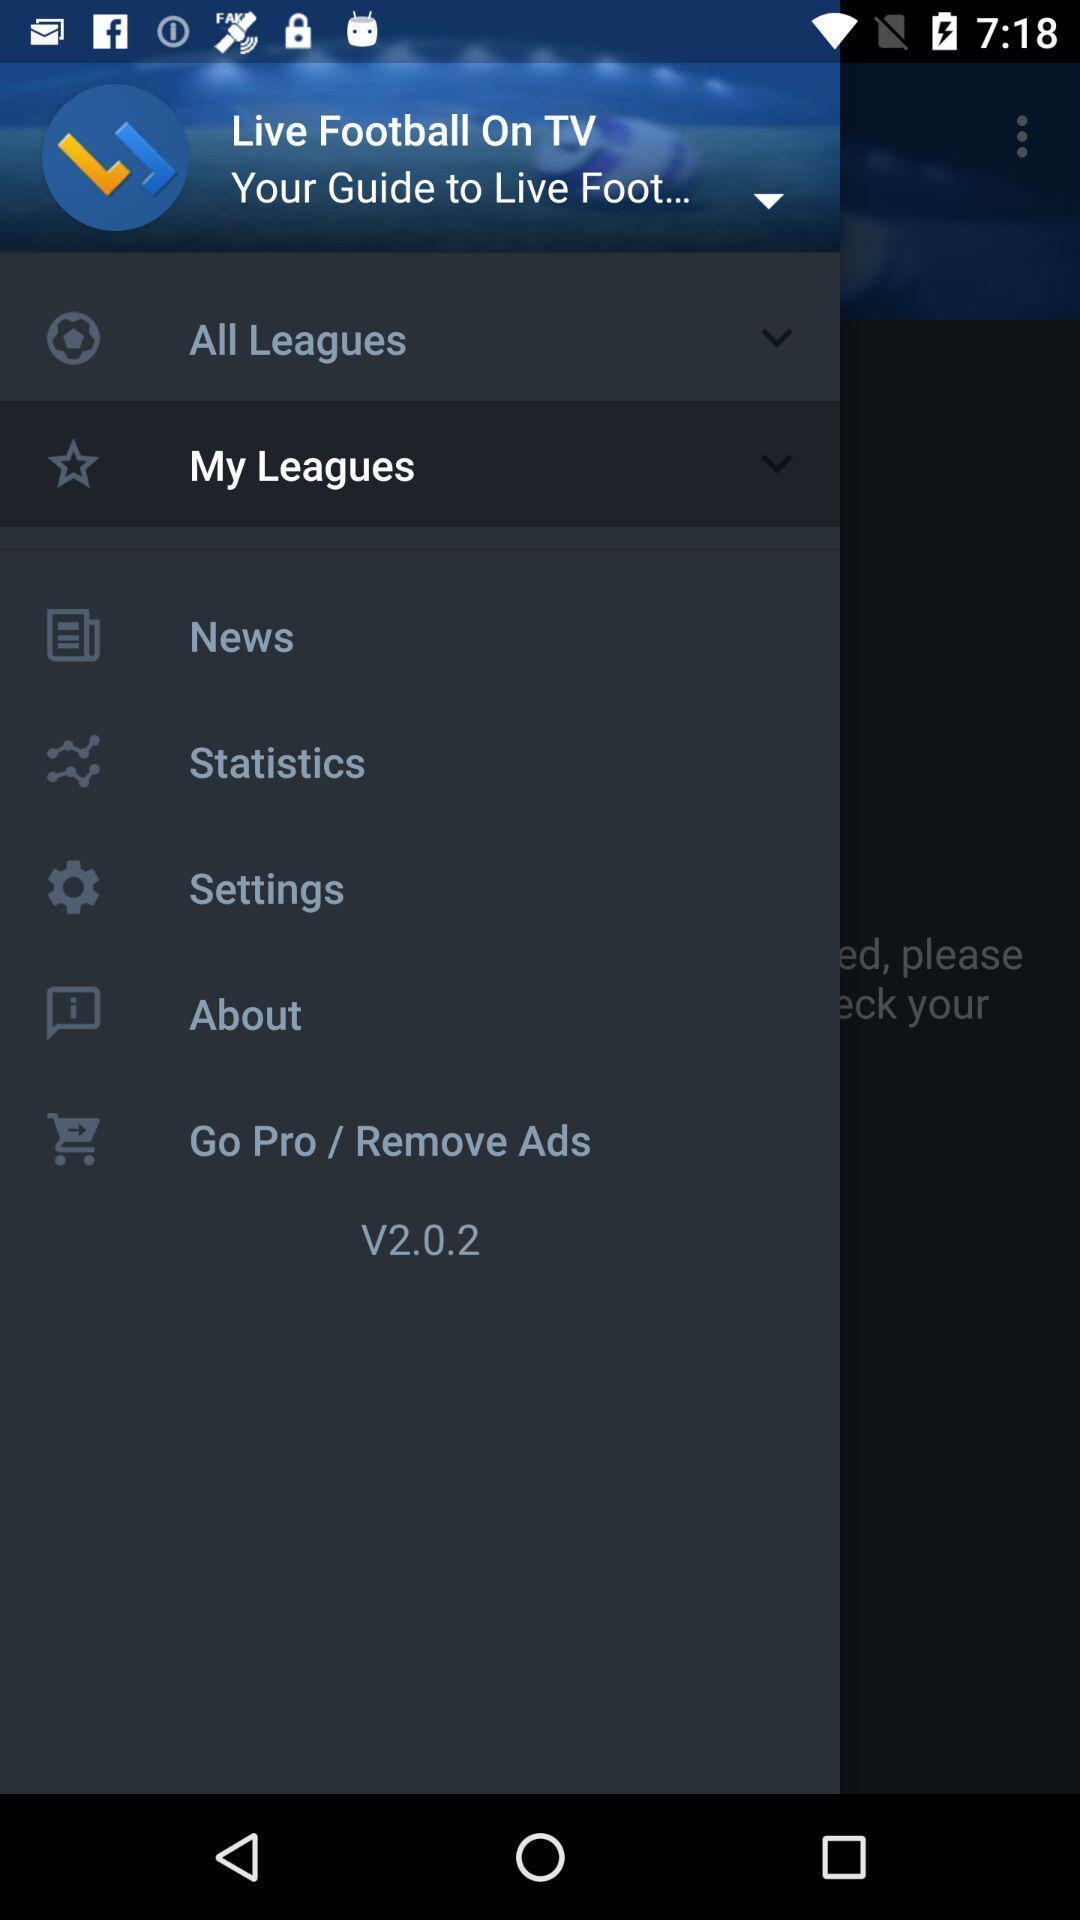What can you discern from this picture? Page showing different options on an app. 